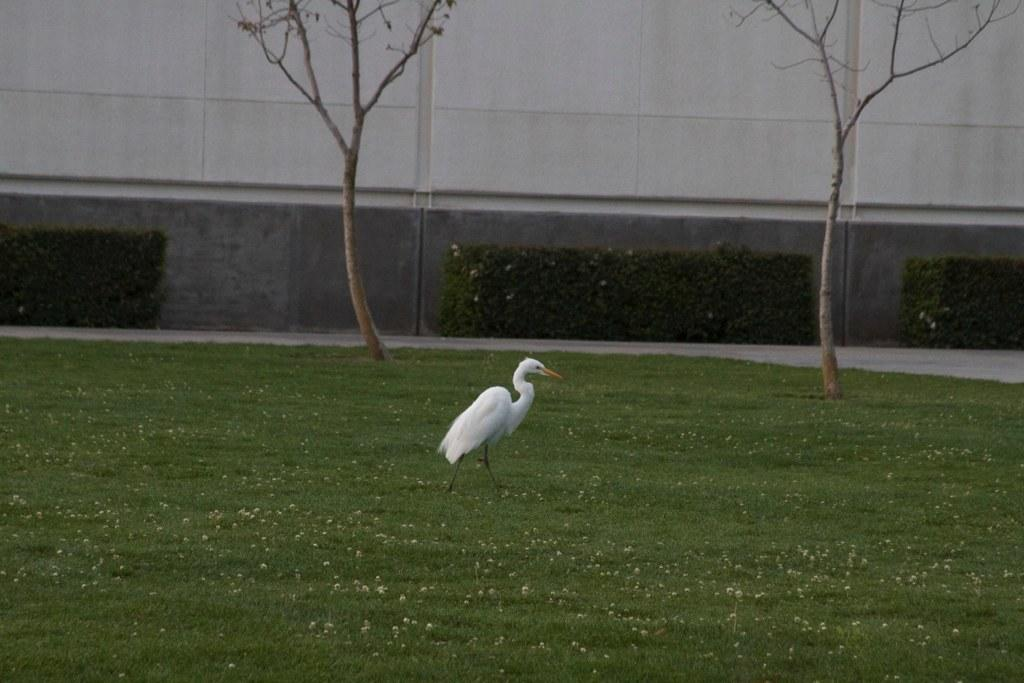What is the main subject of the image? There is a crane in the image. What is the crane doing in the image? The crane is walking on the ground and moving towards the right side. What type of terrain is the crane walking on? There is grass on the ground. What can be seen in the background of the image? There are two trees and a wall in the background. What type of fact can be seen in the image? There is no fact present in the image; it features a crane walking on grass and moving towards the right side. How many engines are visible in the image? There are no engines present in the image. 